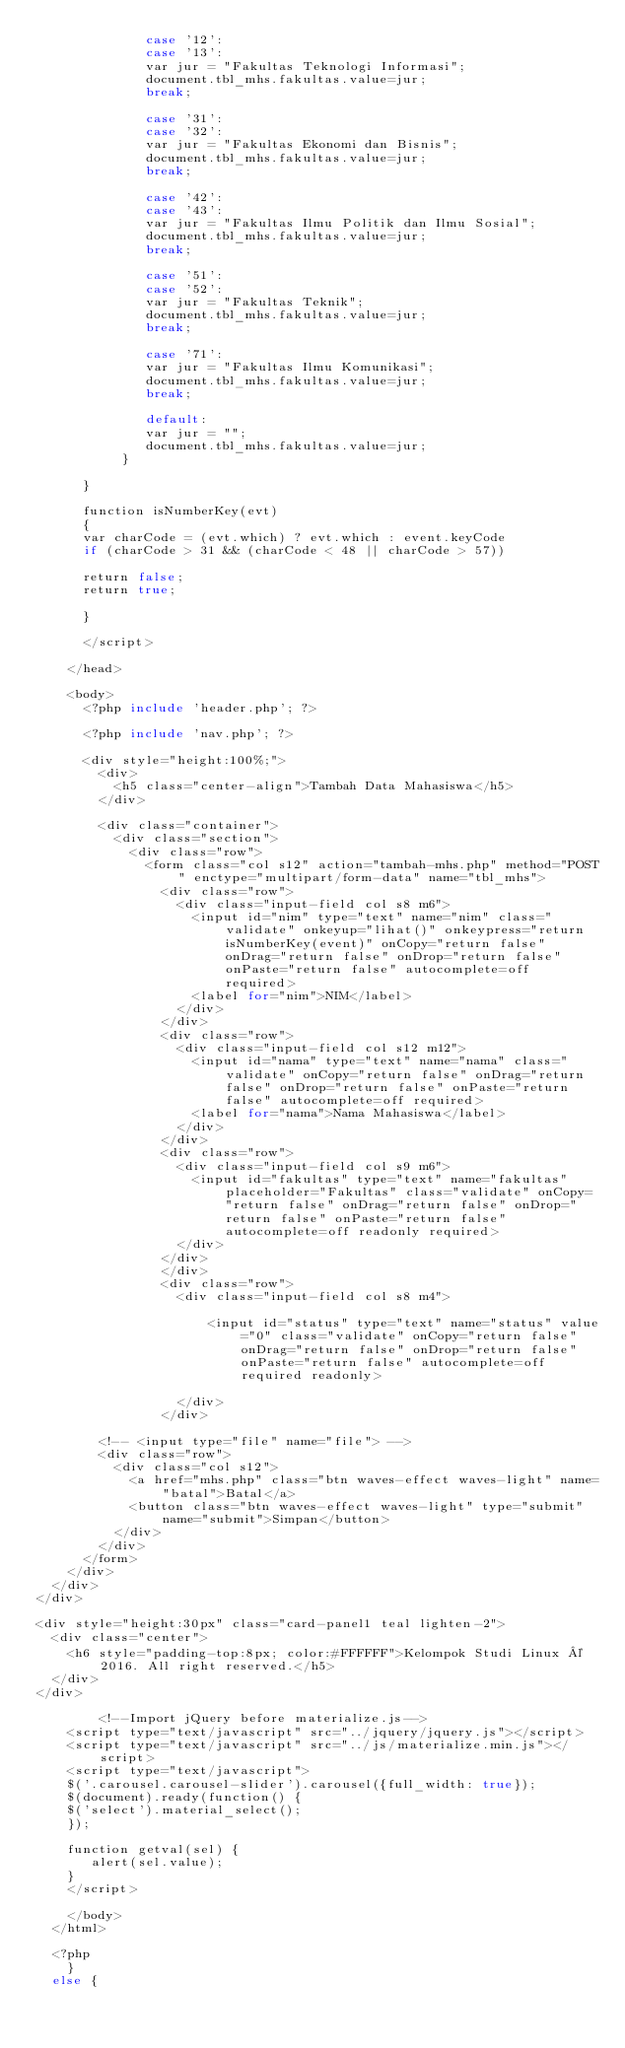<code> <loc_0><loc_0><loc_500><loc_500><_PHP_>              case '12':
              case '13':
              var jur = "Fakultas Teknologi Informasi";
              document.tbl_mhs.fakultas.value=jur;
              break;

              case '31':
              case '32':
              var jur = "Fakultas Ekonomi dan Bisnis";
              document.tbl_mhs.fakultas.value=jur;
              break;

              case '42':
              case '43':
              var jur = "Fakultas Ilmu Politik dan Ilmu Sosial";
              document.tbl_mhs.fakultas.value=jur;
              break;

              case '51':
              case '52':
              var jur = "Fakultas Teknik";
              document.tbl_mhs.fakultas.value=jur;
              break;

              case '71':
              var jur = "Fakultas Ilmu Komunikasi";
              document.tbl_mhs.fakultas.value=jur;
              break;

              default:
              var jur = "";
              document.tbl_mhs.fakultas.value=jur;
           }

      }

      function isNumberKey(evt)
      {
      var charCode = (evt.which) ? evt.which : event.keyCode
      if (charCode > 31 && (charCode < 48 || charCode > 57))

      return false;
      return true;

      }

      </script>

    </head>

    <body>
      <?php include 'header.php'; ?>

      <?php include 'nav.php'; ?>

      <div style="height:100%;">
        <div>
          <h5 class="center-align">Tambah Data Mahasiswa</h5>
        </div>

        <div class="container">
          <div class="section">
            <div class="row">
              <form class="col s12" action="tambah-mhs.php" method="POST" enctype="multipart/form-data" name="tbl_mhs">
                <div class="row">
                  <div class="input-field col s8 m6">
                    <input id="nim" type="text" name="nim" class="validate" onkeyup="lihat()" onkeypress="return isNumberKey(event)" onCopy="return false" onDrag="return false" onDrop="return false" onPaste="return false" autocomplete=off required>
                    <label for="nim">NIM</label>
                  </div>
                </div>
                <div class="row">
                  <div class="input-field col s12 m12">
                    <input id="nama" type="text" name="nama" class="validate" onCopy="return false" onDrag="return false" onDrop="return false" onPaste="return false" autocomplete=off required>
                    <label for="nama">Nama Mahasiswa</label>
                  </div>
                </div>
                <div class="row">
                  <div class="input-field col s9 m6">
                    <input id="fakultas" type="text" name="fakultas" placeholder="Fakultas" class="validate" onCopy="return false" onDrag="return false" onDrop="return false" onPaste="return false" autocomplete=off readonly required>
                  </div>
                </div>
                </div>
                <div class="row">
                  <div class="input-field col s8 m4">

                      <input id="status" type="text" name="status" value="0" class="validate" onCopy="return false" onDrag="return false" onDrop="return false" onPaste="return false" autocomplete=off required readonly>

                  </div>
                </div>

        <!-- <input type="file" name="file"> -->
        <div class="row">
          <div class="col s12">
            <a href="mhs.php" class="btn waves-effect waves-light" name="batal">Batal</a>
      	    <button class="btn waves-effect waves-light" type="submit" name="submit">Simpan</button>
          </div>
        </div>
      </form>
    </div>
  </div>
</div>

<div style="height:30px" class="card-panel1 teal lighten-2">
  <div class="center">
    <h6 style="padding-top:8px; color:#FFFFFF">Kelompok Studi Linux © 2016. All right reserved.</h5>
  </div>
</div>

		<!--Import jQuery before materialize.js-->
    <script type="text/javascript" src="../jquery/jquery.js"></script>
    <script type="text/javascript" src="../js/materialize.min.js"></script>
    <script type="text/javascript">
    $('.carousel.carousel-slider').carousel({full_width: true});
    $(document).ready(function() {
    $('select').material_select();
    });

    function getval(sel) {
       alert(sel.value);
    }
    </script>

	</body>
  </html>

  <?php
    }
  else {</code> 